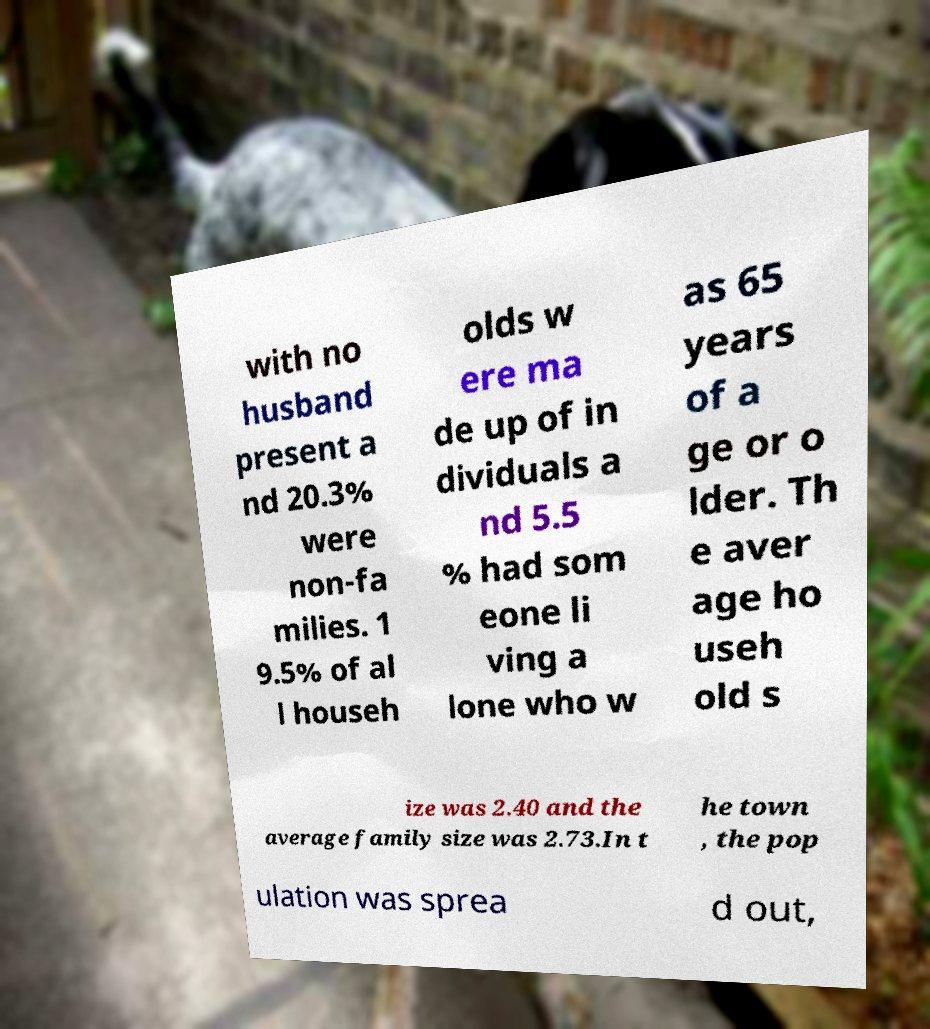I need the written content from this picture converted into text. Can you do that? with no husband present a nd 20.3% were non-fa milies. 1 9.5% of al l househ olds w ere ma de up of in dividuals a nd 5.5 % had som eone li ving a lone who w as 65 years of a ge or o lder. Th e aver age ho useh old s ize was 2.40 and the average family size was 2.73.In t he town , the pop ulation was sprea d out, 